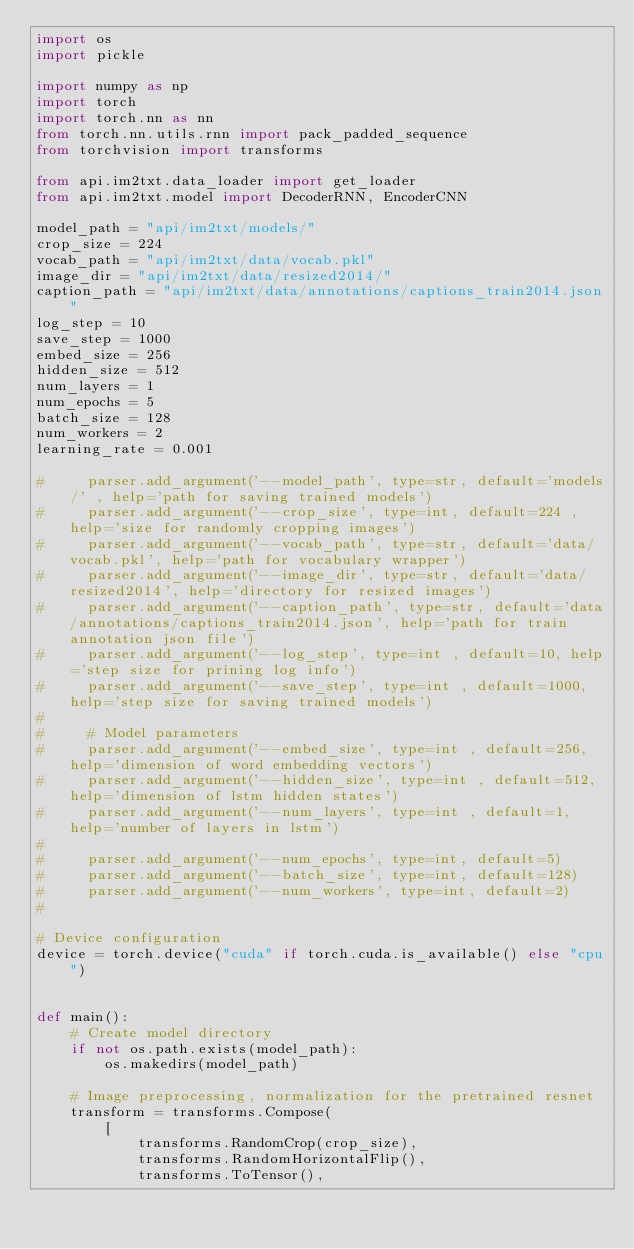<code> <loc_0><loc_0><loc_500><loc_500><_Python_>import os
import pickle

import numpy as np
import torch
import torch.nn as nn
from torch.nn.utils.rnn import pack_padded_sequence
from torchvision import transforms

from api.im2txt.data_loader import get_loader
from api.im2txt.model import DecoderRNN, EncoderCNN

model_path = "api/im2txt/models/"
crop_size = 224
vocab_path = "api/im2txt/data/vocab.pkl"
image_dir = "api/im2txt/data/resized2014/"
caption_path = "api/im2txt/data/annotations/captions_train2014.json"
log_step = 10
save_step = 1000
embed_size = 256
hidden_size = 512
num_layers = 1
num_epochs = 5
batch_size = 128
num_workers = 2
learning_rate = 0.001

#     parser.add_argument('--model_path', type=str, default='models/' , help='path for saving trained models')
#     parser.add_argument('--crop_size', type=int, default=224 , help='size for randomly cropping images')
#     parser.add_argument('--vocab_path', type=str, default='data/vocab.pkl', help='path for vocabulary wrapper')
#     parser.add_argument('--image_dir', type=str, default='data/resized2014', help='directory for resized images')
#     parser.add_argument('--caption_path', type=str, default='data/annotations/captions_train2014.json', help='path for train annotation json file')
#     parser.add_argument('--log_step', type=int , default=10, help='step size for prining log info')
#     parser.add_argument('--save_step', type=int , default=1000, help='step size for saving trained models')
#
#     # Model parameters
#     parser.add_argument('--embed_size', type=int , default=256, help='dimension of word embedding vectors')
#     parser.add_argument('--hidden_size', type=int , default=512, help='dimension of lstm hidden states')
#     parser.add_argument('--num_layers', type=int , default=1, help='number of layers in lstm')
#
#     parser.add_argument('--num_epochs', type=int, default=5)
#     parser.add_argument('--batch_size', type=int, default=128)
#     parser.add_argument('--num_workers', type=int, default=2)
#

# Device configuration
device = torch.device("cuda" if torch.cuda.is_available() else "cpu")


def main():
    # Create model directory
    if not os.path.exists(model_path):
        os.makedirs(model_path)

    # Image preprocessing, normalization for the pretrained resnet
    transform = transforms.Compose(
        [
            transforms.RandomCrop(crop_size),
            transforms.RandomHorizontalFlip(),
            transforms.ToTensor(),</code> 